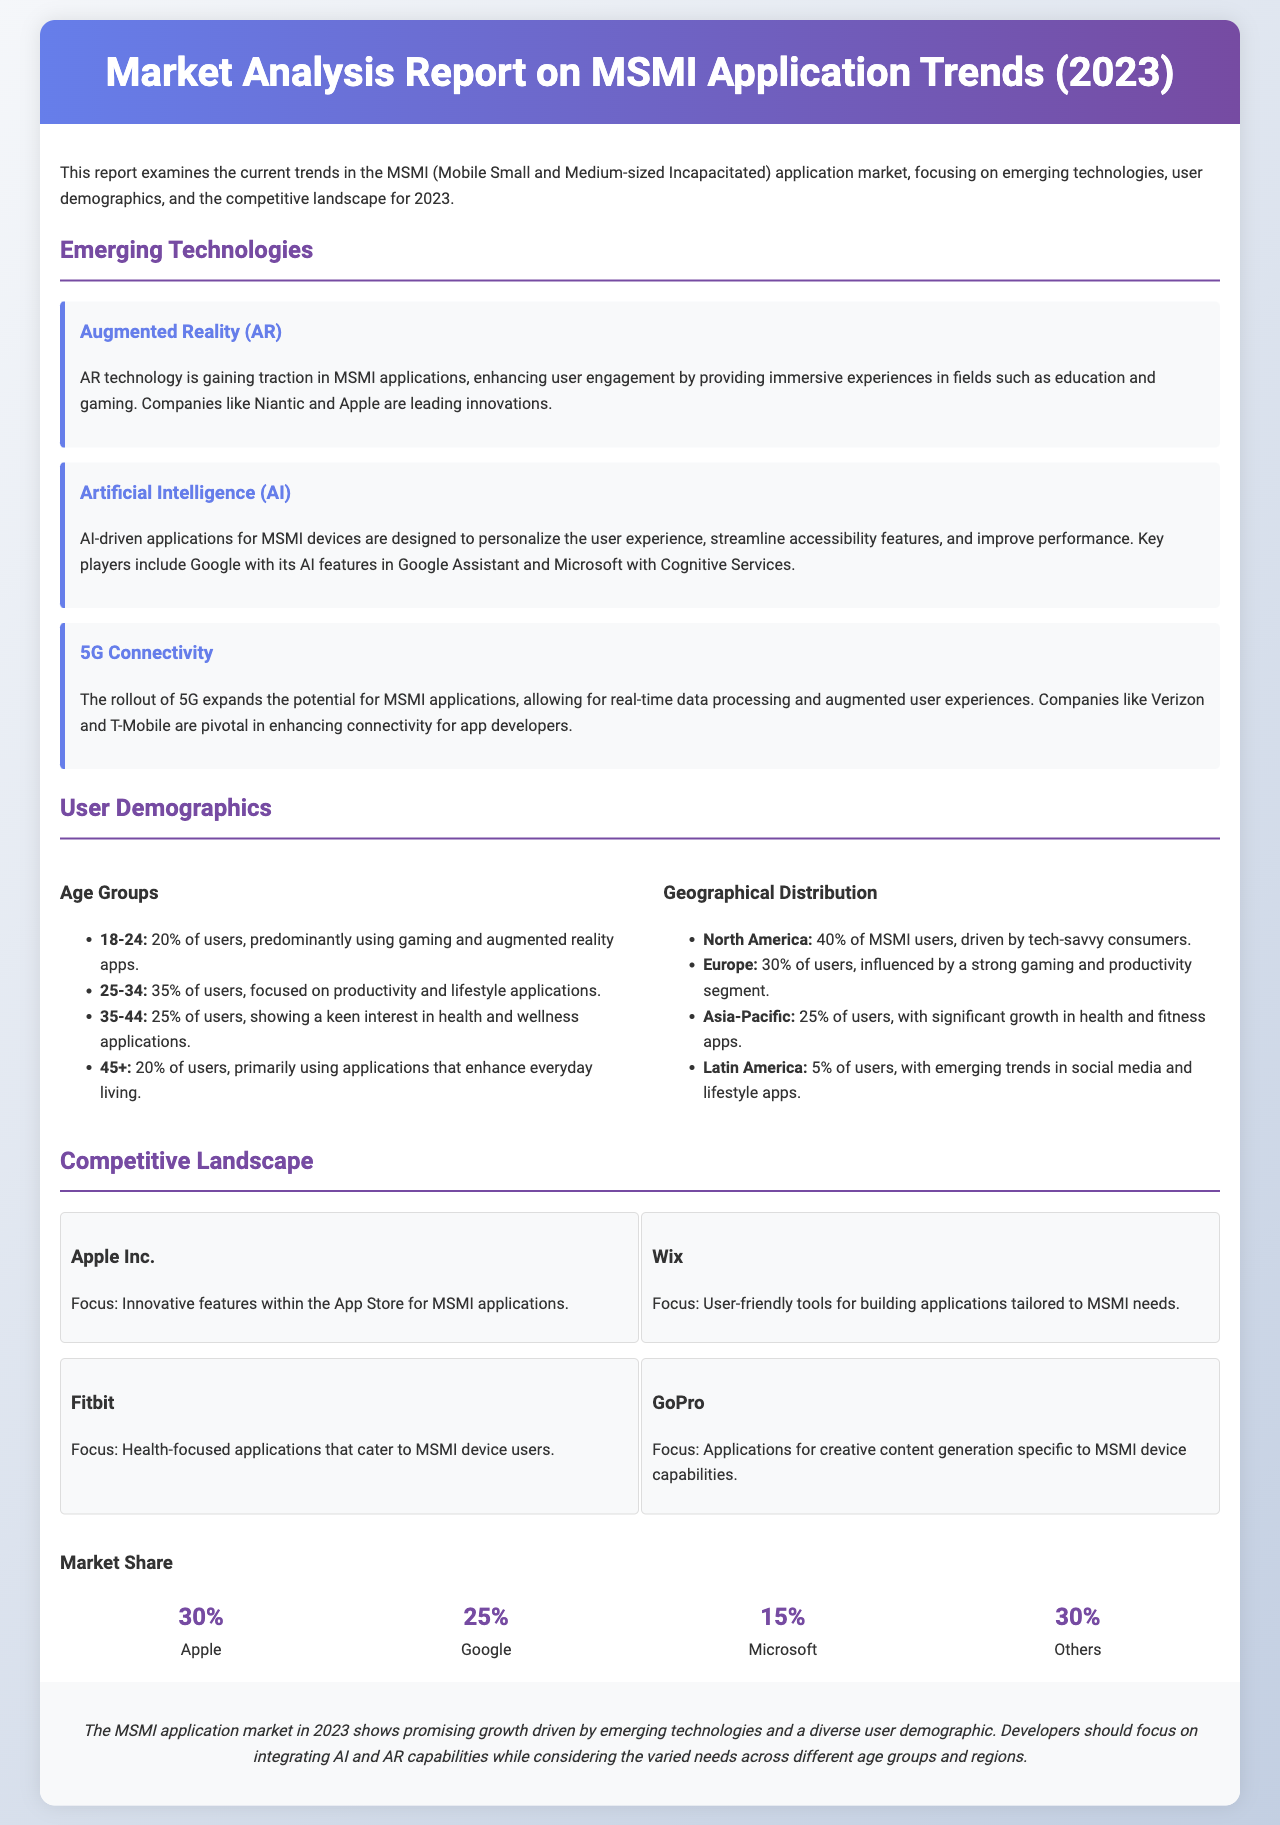What percentage of users are aged 25-34? The percentage of users aged 25-34 is stated in the demographics section as 35%.
Answer: 35% Which company is focused on health-focused applications? The document lists Fitbit as focusing on health-focused applications for MSMI device users.
Answer: Fitbit What technology is primarily used for immersive experiences in education and gaming? The emerging technology section highlights Augmented Reality (AR) as enhancing user engagement through immersive experiences.
Answer: Augmented Reality (AR) What is the market share percentage held by Google? The market share section indicates the percentage for Google to be 25%.
Answer: 25% Which geographical region has the highest percentage of MSMI users? The demographics section notes North America as having 40% of MSMI users.
Answer: North America What emerging technology is associated with real-time data processing? The report mentions 5G Connectivity as expanding the potential for real-time data processing in MSMI applications.
Answer: 5G Connectivity How many companies are listed in the competitive landscape section? The document presents 4 companies in the competitive landscape section.
Answer: 4 Which age group primarily uses applications that enhance everyday living? The 45+ age group is highlighted as primarily using applications that enhance everyday living.
Answer: 45+ 